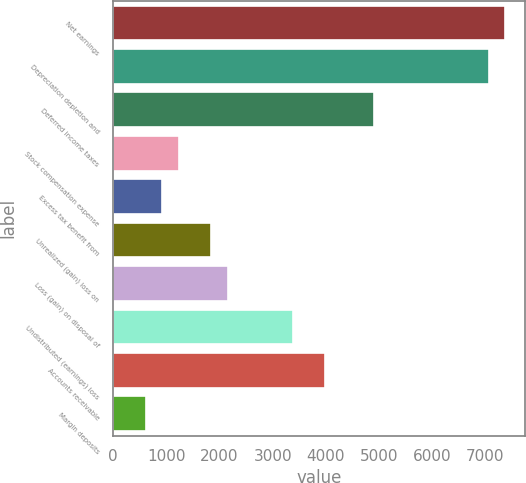<chart> <loc_0><loc_0><loc_500><loc_500><bar_chart><fcel>Net earnings<fcel>Depreciation depletion and<fcel>Deferred income taxes<fcel>Stock compensation expense<fcel>Excess tax benefit from<fcel>Unrealized (gain) loss on<fcel>Loss (gain) on disposal of<fcel>Undistributed (earnings) loss<fcel>Accounts receivable<fcel>Margin deposits<nl><fcel>7367.64<fcel>7060.68<fcel>4911.96<fcel>1228.44<fcel>921.48<fcel>1842.36<fcel>2149.32<fcel>3377.16<fcel>3991.08<fcel>614.52<nl></chart> 